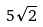<formula> <loc_0><loc_0><loc_500><loc_500>5 \sqrt { 2 }</formula> 